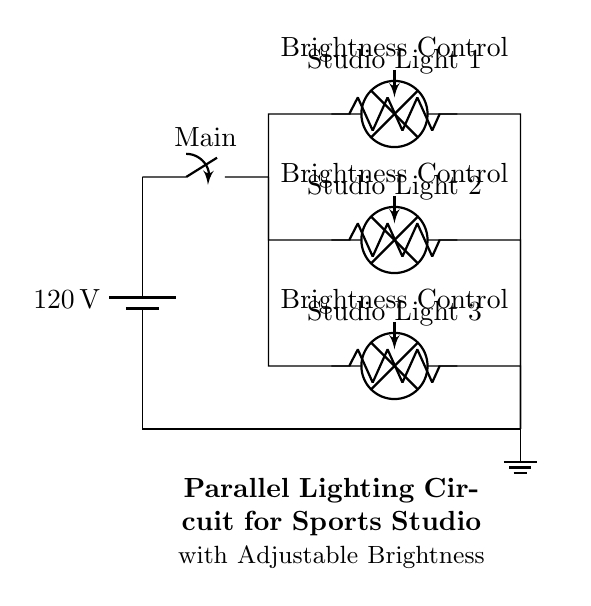What is the voltage of the circuit? The voltage of the circuit is indicated by the battery symbol at the top left corner, which shows a value of 120 volts.
Answer: 120 volts How many studio lights are there? The diagram shows three branches leading to different lamps labeled Studio Light 1, Studio Light 2, and Studio Light 3. Therefore, there are three studio lights in total.
Answer: Three What function do the potentiometers serve? Each of the three potentiometers connected in series with the studio lights acts as a brightness control, allowing adjustment of each light's intensity.
Answer: Brightness control What type of circuit is this? The circuit diagram illustrates a parallel configuration since all the lamps are connected across the same voltage source, allowing each light to operate independently.
Answer: Parallel If one lamp fails, what happens to the other lamps? In a parallel circuit, if one lamp fails, the others remain functional as they are independently connected to the voltage source. This is a key trait of parallel circuits.
Answer: Other lamps stay on What type of switch is used in the circuit? The diagram shows a main switch symbol, indicating a simple on-off switch that can control the overall circuit's power supply.
Answer: Main switch 